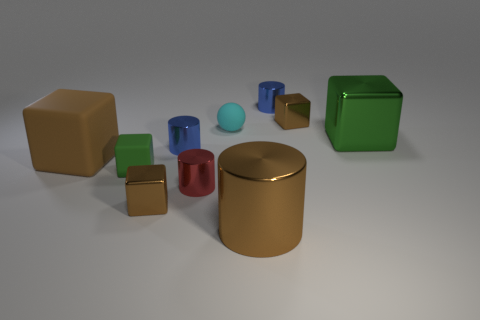Subtract all tiny cubes. How many cubes are left? 2 Subtract all red cylinders. How many cylinders are left? 3 Subtract 2 cylinders. How many cylinders are left? 2 Subtract all cylinders. How many objects are left? 6 Subtract 0 purple spheres. How many objects are left? 10 Subtract all purple cylinders. Subtract all green cubes. How many cylinders are left? 4 Subtract all purple spheres. How many red cylinders are left? 1 Subtract all green metallic spheres. Subtract all tiny matte balls. How many objects are left? 9 Add 7 small brown metallic things. How many small brown metallic things are left? 9 Add 6 large gray shiny blocks. How many large gray shiny blocks exist? 6 